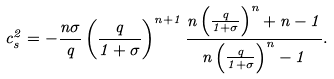<formula> <loc_0><loc_0><loc_500><loc_500>c _ { s } ^ { 2 } = - \frac { n \sigma } { q } \left ( \frac { q } { 1 + \sigma } \right ) ^ { n + 1 } \frac { n \left ( \frac { q } { 1 + \sigma } \right ) ^ { n } + n - 1 } { n \left ( \frac { q } { 1 + \sigma } \right ) ^ { n } - 1 } .</formula> 